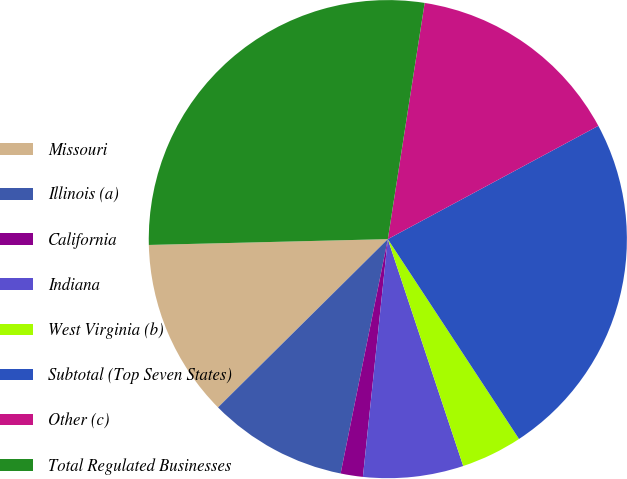Convert chart to OTSL. <chart><loc_0><loc_0><loc_500><loc_500><pie_chart><fcel>Missouri<fcel>Illinois (a)<fcel>California<fcel>Indiana<fcel>West Virginia (b)<fcel>Subtotal (Top Seven States)<fcel>Other (c)<fcel>Total Regulated Businesses<nl><fcel>12.04%<fcel>9.41%<fcel>1.5%<fcel>6.77%<fcel>4.14%<fcel>23.61%<fcel>14.68%<fcel>27.85%<nl></chart> 